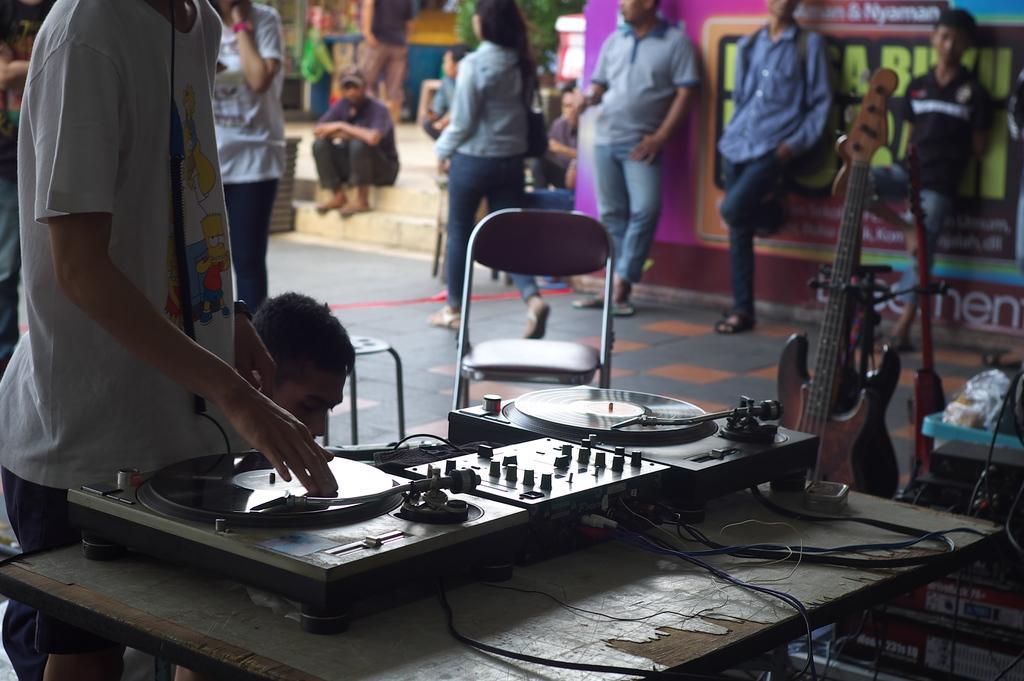Could you give a brief overview of what you see in this image? In this image we can see a person operating the DJ mixer which is placed on the table. We can also see a chair, stool and a person sitting beside it. On the right side we can see some musical instruments. On the backside we can see a group of people standing beside a wall, a woman walking on the ground and a person sitting on the stairs. 